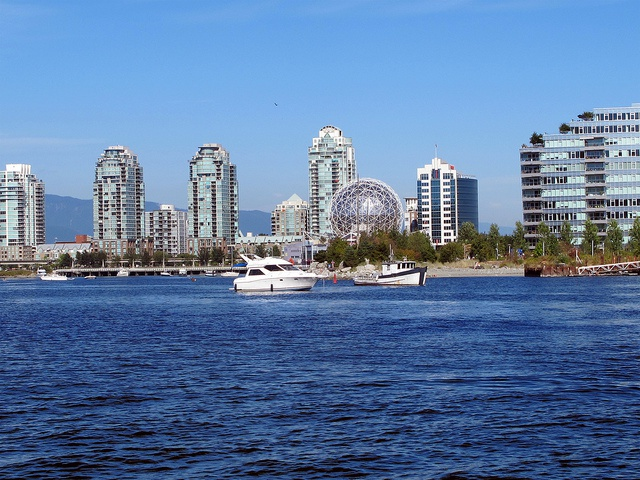Describe the objects in this image and their specific colors. I can see boat in lightblue, white, darkgray, gray, and black tones, boat in lightblue, lightgray, darkgray, black, and gray tones, boat in lightblue, white, gray, and darkgray tones, boat in lightblue, lightgray, darkgray, and gray tones, and boat in lightblue, lightgray, darkgray, and gray tones in this image. 